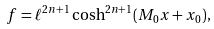Convert formula to latex. <formula><loc_0><loc_0><loc_500><loc_500>f = \ell ^ { 2 n + 1 } \cosh ^ { 2 n + 1 } ( M _ { 0 } x + x _ { 0 } ) ,</formula> 